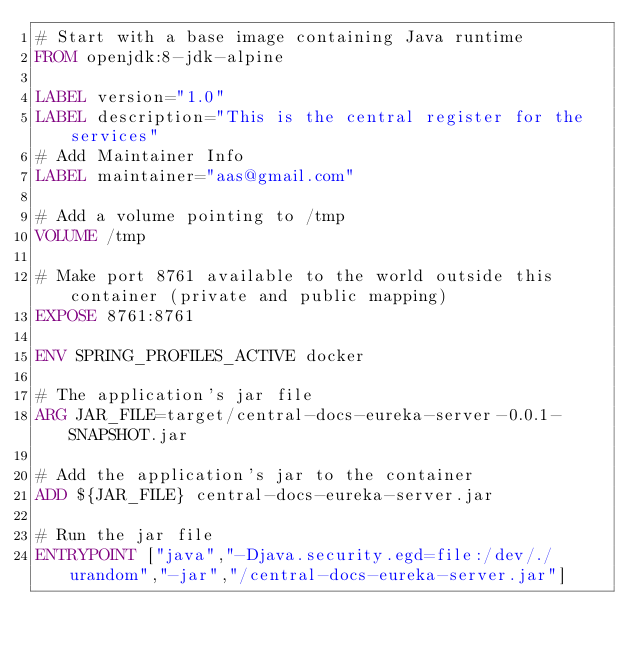Convert code to text. <code><loc_0><loc_0><loc_500><loc_500><_Dockerfile_># Start with a base image containing Java runtime
FROM openjdk:8-jdk-alpine

LABEL version="1.0"
LABEL description="This is the central register for the services"
# Add Maintainer Info
LABEL maintainer="aas@gmail.com"

# Add a volume pointing to /tmp
VOLUME /tmp

# Make port 8761 available to the world outside this container (private and public mapping)
EXPOSE 8761:8761

ENV SPRING_PROFILES_ACTIVE docker

# The application's jar file
ARG JAR_FILE=target/central-docs-eureka-server-0.0.1-SNAPSHOT.jar

# Add the application's jar to the container
ADD ${JAR_FILE} central-docs-eureka-server.jar

# Run the jar file
ENTRYPOINT ["java","-Djava.security.egd=file:/dev/./urandom","-jar","/central-docs-eureka-server.jar"]
</code> 